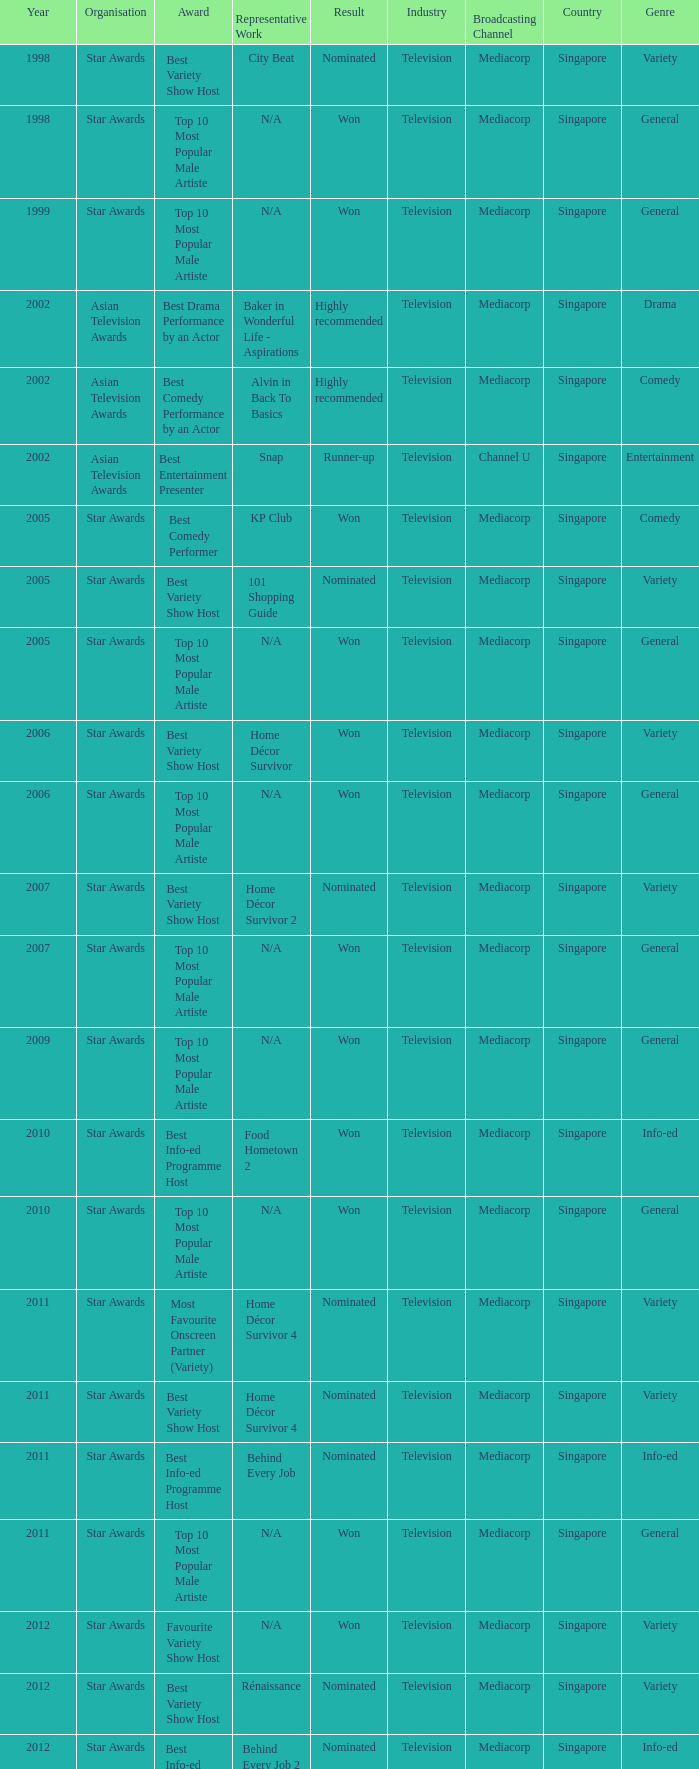What is the organisation in 2011 that was nominated and the award of best info-ed programme host? Star Awards. 